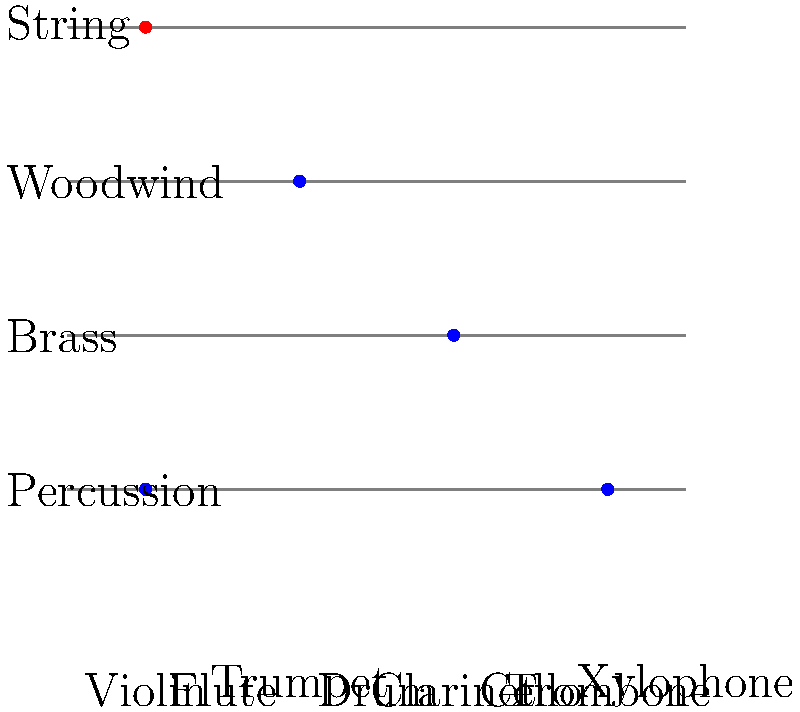Match the musical instruments to their correct family (string, woodwind, brass, or percussion) by drawing lines between them. Which instrument is incorrectly matched? Let's go through each instrument and its correct family:

1. Violin: String family (correctly matched)
2. Flute: Woodwind family (correctly matched)
3. Trumpet: Brass family (correctly matched)
4. Drum: Percussion family (correctly matched)
5. Clarinet: Woodwind family (incorrectly matched to Percussion)
6. Cello: String family (correctly matched)
7. Trombone: Brass family (correctly matched)
8. Xylophone: Percussion family (correctly matched)

The clarinet is the only instrument that is incorrectly matched. It belongs to the woodwind family, but in the diagram, it is connected to the percussion family.
Answer: Clarinet 